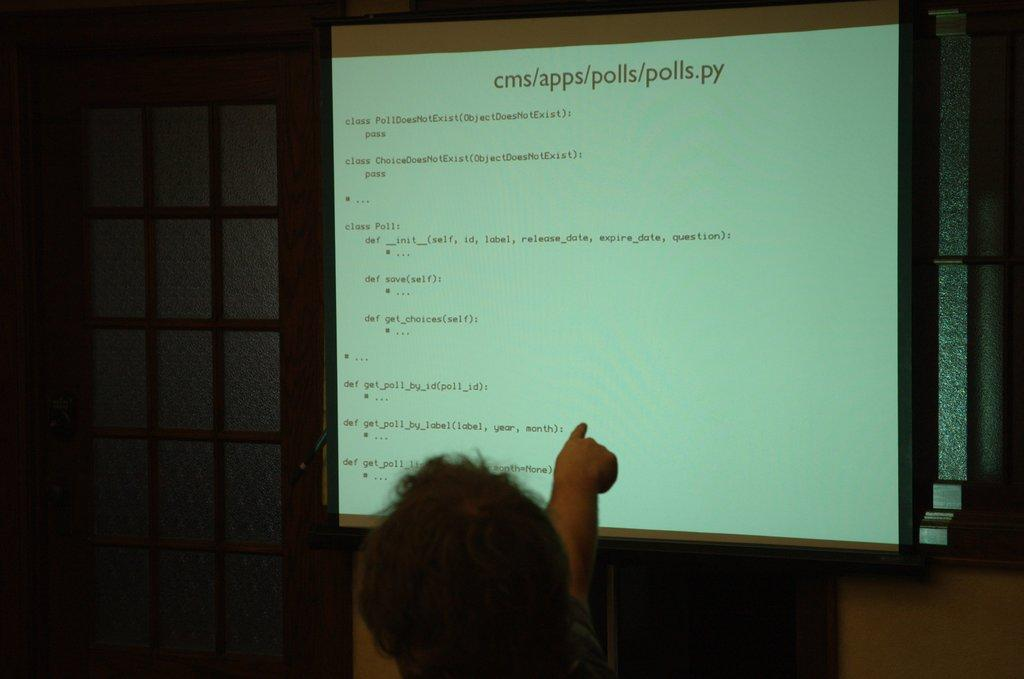What is the main object in the image? There is a projector board present in the image. What is displayed on the projector board? There is text on the projector board. Can you describe the person in the image? There is a person at the bottom of the image. What can be seen in the background of the image? There are windows in the background of the image. What is the structure of the windows? The windows are part of a wall. What type of scene is being traded between the two people in the image? There are no people trading a scene in the image; it only features a projector board with text and a person at the bottom. Is there a note attached to the projector board in the image? There is no note present on the projector board in the image. 